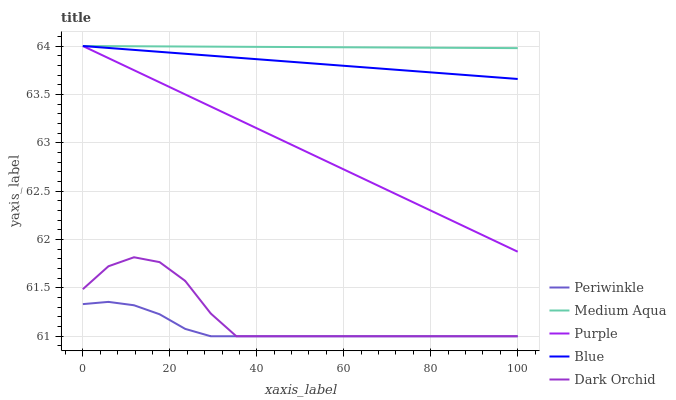Does Periwinkle have the minimum area under the curve?
Answer yes or no. Yes. Does Medium Aqua have the maximum area under the curve?
Answer yes or no. Yes. Does Medium Aqua have the minimum area under the curve?
Answer yes or no. No. Does Periwinkle have the maximum area under the curve?
Answer yes or no. No. Is Medium Aqua the smoothest?
Answer yes or no. Yes. Is Dark Orchid the roughest?
Answer yes or no. Yes. Is Periwinkle the smoothest?
Answer yes or no. No. Is Periwinkle the roughest?
Answer yes or no. No. Does Periwinkle have the lowest value?
Answer yes or no. Yes. Does Medium Aqua have the lowest value?
Answer yes or no. No. Does Blue have the highest value?
Answer yes or no. Yes. Does Periwinkle have the highest value?
Answer yes or no. No. Is Dark Orchid less than Blue?
Answer yes or no. Yes. Is Blue greater than Periwinkle?
Answer yes or no. Yes. Does Periwinkle intersect Dark Orchid?
Answer yes or no. Yes. Is Periwinkle less than Dark Orchid?
Answer yes or no. No. Is Periwinkle greater than Dark Orchid?
Answer yes or no. No. Does Dark Orchid intersect Blue?
Answer yes or no. No. 